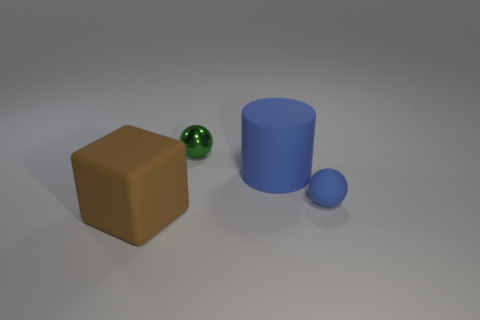Are there the same number of green metal balls that are left of the blue sphere and matte blocks on the right side of the rubber block?
Your response must be concise. No. Is there another block made of the same material as the brown cube?
Keep it short and to the point. No. Does the tiny ball behind the tiny matte ball have the same material as the large block?
Ensure brevity in your answer.  No. What size is the object that is both right of the small green ball and behind the small blue thing?
Provide a succinct answer. Large. What is the color of the matte cube?
Offer a terse response. Brown. What number of large brown metallic objects are there?
Provide a succinct answer. 0. How many large rubber cylinders are the same color as the tiny metallic thing?
Your answer should be compact. 0. There is a blue matte thing that is on the right side of the blue cylinder; does it have the same shape as the large matte thing to the left of the green metal sphere?
Offer a terse response. No. There is a tiny object that is to the right of the blue rubber object on the left side of the ball that is right of the shiny object; what color is it?
Your answer should be very brief. Blue. There is a big matte object behind the brown thing; what is its color?
Your answer should be compact. Blue. 